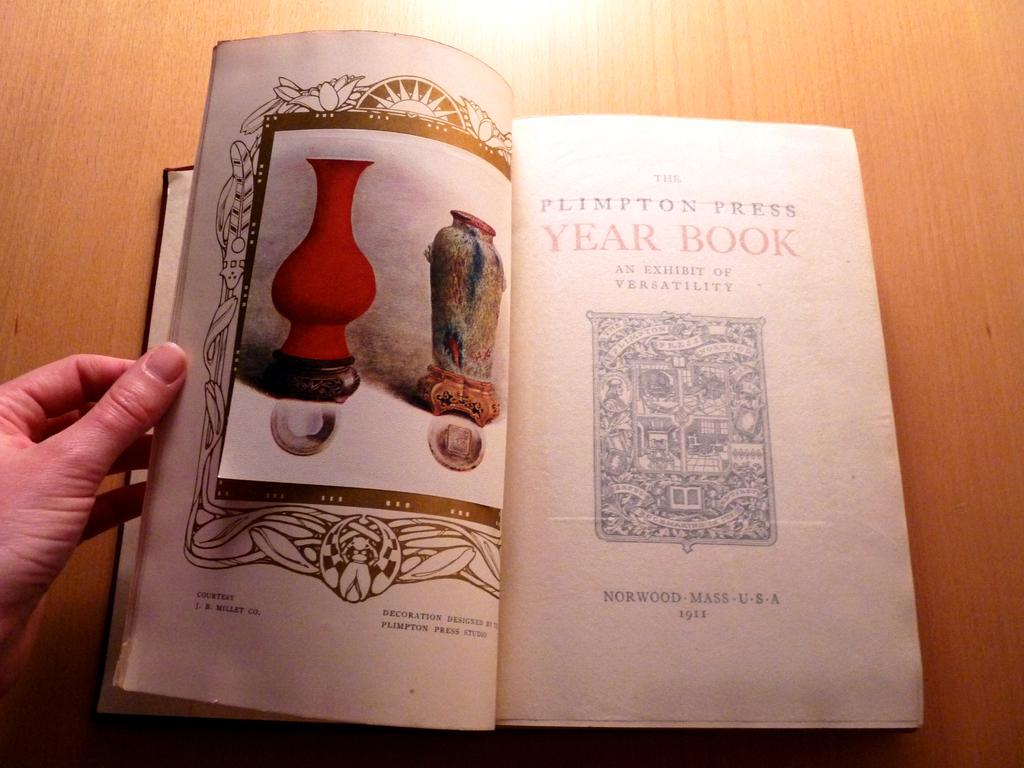Is this a year book?
Provide a succinct answer. Yes. 